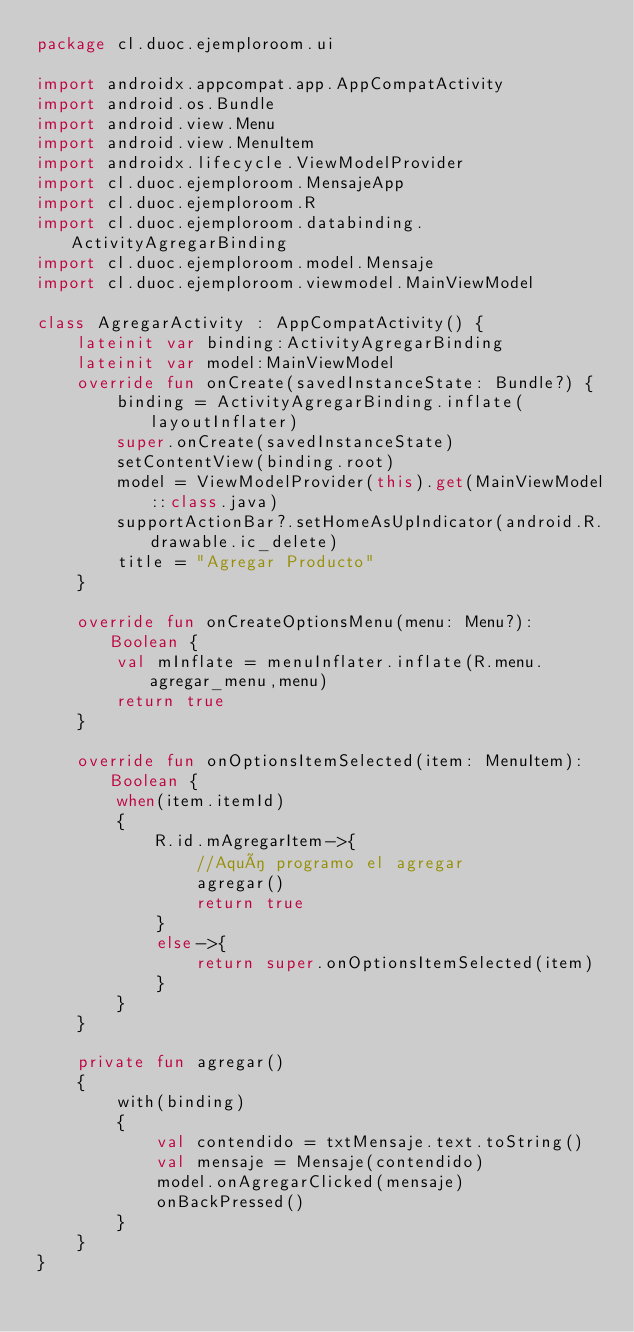<code> <loc_0><loc_0><loc_500><loc_500><_Kotlin_>package cl.duoc.ejemploroom.ui

import androidx.appcompat.app.AppCompatActivity
import android.os.Bundle
import android.view.Menu
import android.view.MenuItem
import androidx.lifecycle.ViewModelProvider
import cl.duoc.ejemploroom.MensajeApp
import cl.duoc.ejemploroom.R
import cl.duoc.ejemploroom.databinding.ActivityAgregarBinding
import cl.duoc.ejemploroom.model.Mensaje
import cl.duoc.ejemploroom.viewmodel.MainViewModel

class AgregarActivity : AppCompatActivity() {
    lateinit var binding:ActivityAgregarBinding
    lateinit var model:MainViewModel
    override fun onCreate(savedInstanceState: Bundle?) {
        binding = ActivityAgregarBinding.inflate(layoutInflater)
        super.onCreate(savedInstanceState)
        setContentView(binding.root)
        model = ViewModelProvider(this).get(MainViewModel::class.java)
        supportActionBar?.setHomeAsUpIndicator(android.R.drawable.ic_delete)
        title = "Agregar Producto"
    }

    override fun onCreateOptionsMenu(menu: Menu?): Boolean {
        val mInflate = menuInflater.inflate(R.menu.agregar_menu,menu)
        return true
    }

    override fun onOptionsItemSelected(item: MenuItem): Boolean {
        when(item.itemId)
        {
            R.id.mAgregarItem->{
                //Aquí programo el agregar
                agregar()
                return true
            }
            else->{
                return super.onOptionsItemSelected(item)
            }
        }
    }

    private fun agregar()
    {
        with(binding)
        {
            val contendido = txtMensaje.text.toString()
            val mensaje = Mensaje(contendido)
            model.onAgregarClicked(mensaje)
            onBackPressed()
        }
    }
}</code> 